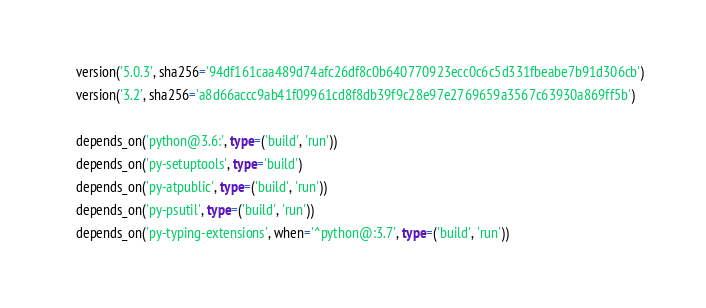<code> <loc_0><loc_0><loc_500><loc_500><_Python_>    version('5.0.3', sha256='94df161caa489d74afc26df8c0b640770923ecc0c6c5d331fbeabe7b91d306cb')
    version('3.2', sha256='a8d66accc9ab41f09961cd8f8db39f9c28e97e2769659a3567c63930a869ff5b')

    depends_on('python@3.6:', type=('build', 'run'))
    depends_on('py-setuptools', type='build')
    depends_on('py-atpublic', type=('build', 'run'))
    depends_on('py-psutil', type=('build', 'run'))
    depends_on('py-typing-extensions', when='^python@:3.7', type=('build', 'run'))
</code> 